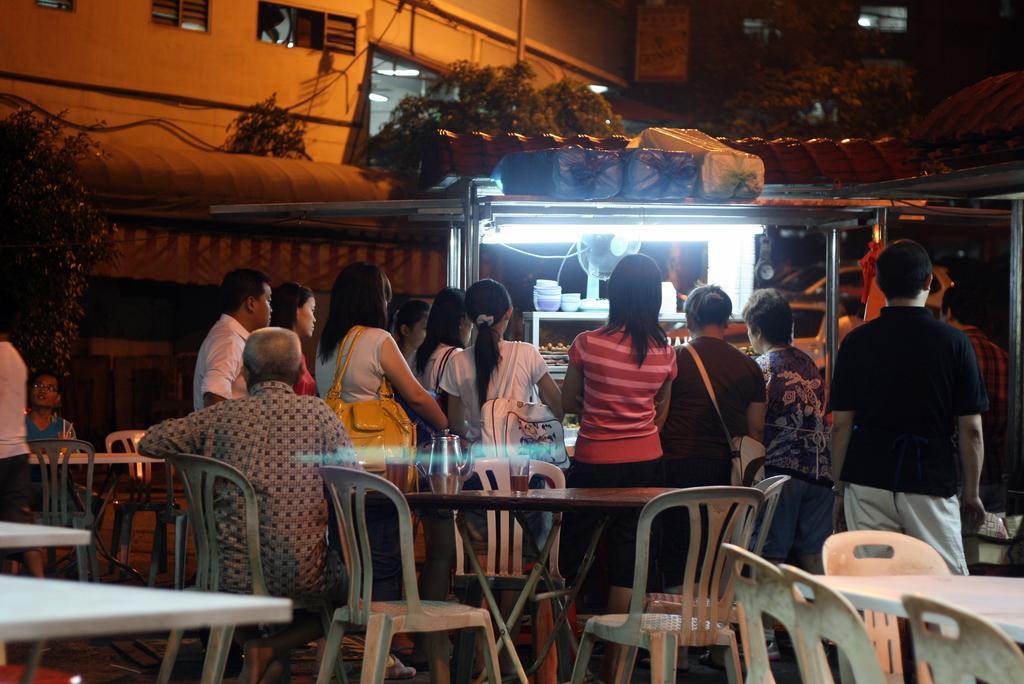Can you describe this image briefly? At the top we can see building with windows and trees. Here we can see all the persons standing near to the store. We can see few persons sitting on the chairs in front of a table and on the table we can see a jar. We can see lot many empty chairs and tables. 